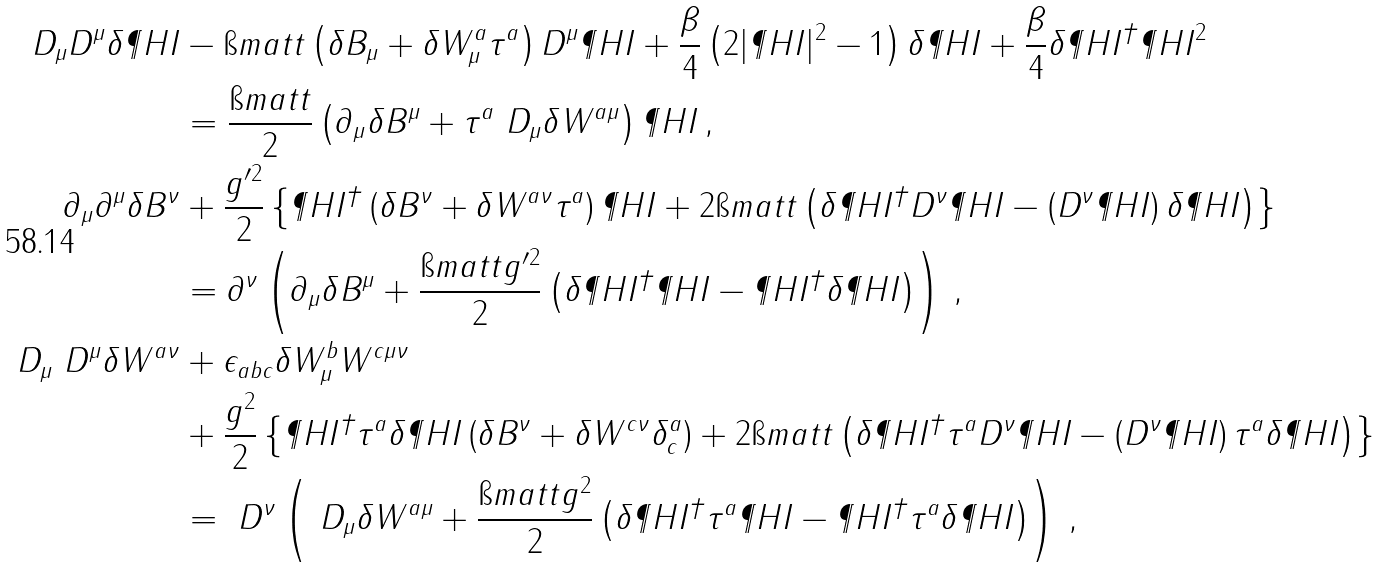Convert formula to latex. <formula><loc_0><loc_0><loc_500><loc_500>D _ { \mu } D ^ { \mu } \delta \P H I & - \i m a t t \left ( \delta B _ { \mu } + \delta W ^ { a } _ { \mu } \tau ^ { a } \right ) D ^ { \mu } \P H I + \frac { \beta } { 4 } \left ( 2 | \P H I | ^ { 2 } - 1 \right ) \delta \P H I + \frac { \beta } { 4 } \delta \P H I ^ { \dagger } \P H I ^ { 2 } \\ & = \frac { \i m a t t } { 2 } \left ( \partial _ { \mu } \delta B ^ { \mu } + \tau ^ { a } \ D _ { \mu } \delta W ^ { a \mu } \right ) \P H I \, , \\ \partial _ { \mu } \partial ^ { \mu } \delta B ^ { \nu } & + \frac { g ^ { \prime 2 } } { 2 } \left \{ \P H I ^ { \dagger } \left ( \delta B ^ { \nu } + \delta W ^ { a \nu } \tau ^ { a } \right ) \P H I + 2 \i m a t t \left ( \delta \P H I ^ { \dagger } D ^ { \nu } \P H I - \left ( D ^ { \nu } \P H I \right ) \delta \P H I \right ) \right \} \\ & = \partial ^ { \nu } \left ( \partial _ { \mu } \delta B ^ { \mu } + \frac { \i m a t t g ^ { \prime 2 } } { 2 } \left ( \delta \P H I ^ { \dagger } \P H I - \P H I ^ { \dagger } \delta \P H I \right ) \right ) \, , \\ \ D _ { \mu } \ D ^ { \mu } \delta W ^ { a \nu } & + \epsilon _ { a b c } \delta W ^ { b } _ { \mu } W ^ { c \mu \nu } \\ & + \frac { g ^ { 2 } } { 2 } \left \{ \P H I ^ { \dagger } \tau ^ { a } \delta \P H I \left ( \delta B ^ { \nu } + \delta W ^ { c \nu } \delta ^ { a } _ { c } \right ) + 2 \i m a t t \left ( \delta \P H I ^ { \dagger } \tau ^ { a } D ^ { \nu } \P H I - \left ( D ^ { \nu } \P H I \right ) \tau ^ { a } \delta \P H I \right ) \right \} \\ & = \ D ^ { \nu } \left ( \ D _ { \mu } \delta W ^ { a \mu } + \frac { \i m a t t g ^ { 2 } } { 2 } \left ( \delta \P H I ^ { \dagger } \tau ^ { a } \P H I - \P H I ^ { \dagger } \tau ^ { a } \delta \P H I \right ) \right ) \, ,</formula> 